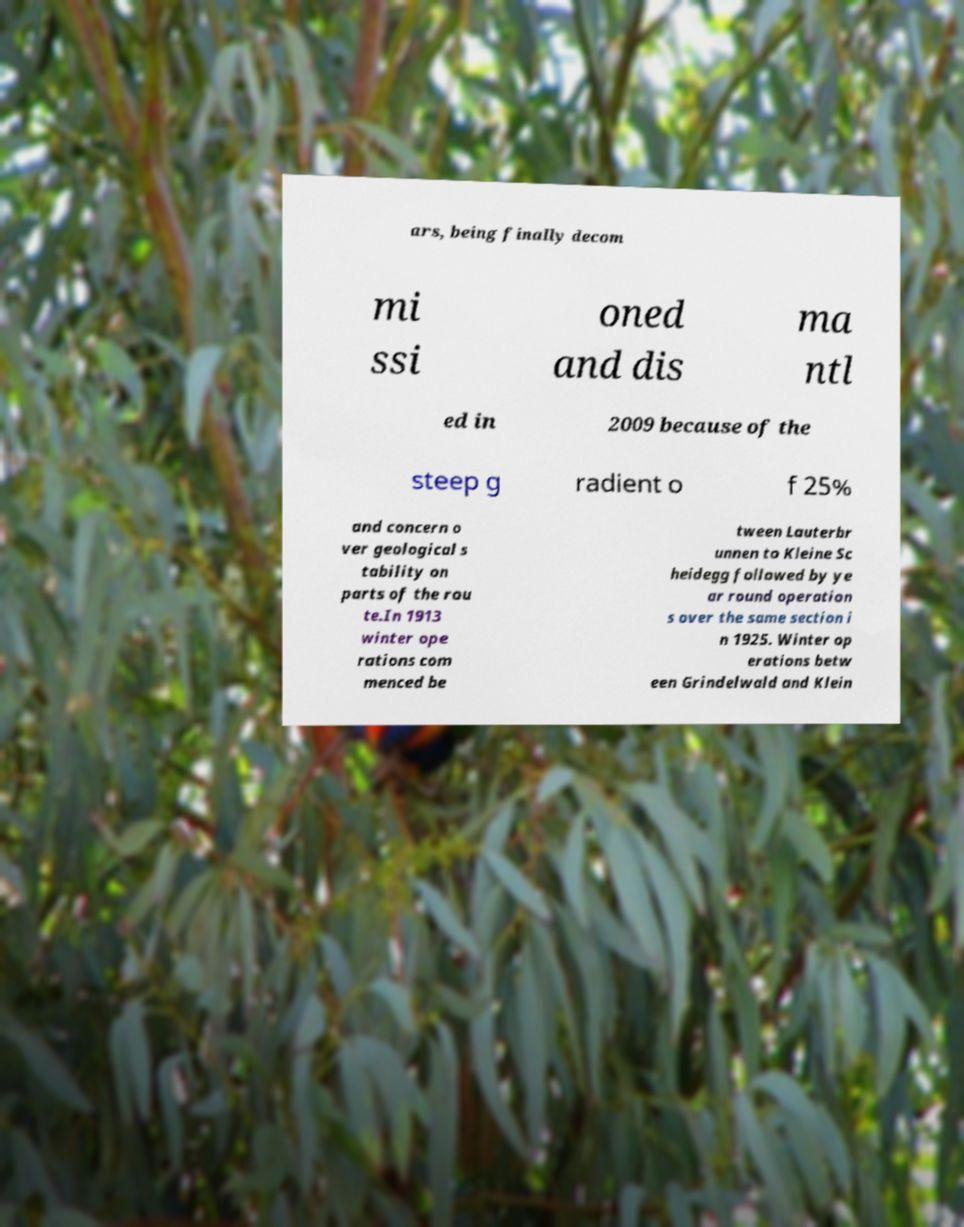Please identify and transcribe the text found in this image. ars, being finally decom mi ssi oned and dis ma ntl ed in 2009 because of the steep g radient o f 25% and concern o ver geological s tability on parts of the rou te.In 1913 winter ope rations com menced be tween Lauterbr unnen to Kleine Sc heidegg followed by ye ar round operation s over the same section i n 1925. Winter op erations betw een Grindelwald and Klein 